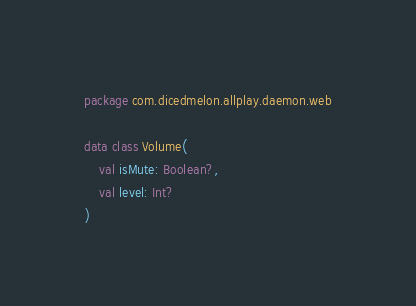<code> <loc_0><loc_0><loc_500><loc_500><_Kotlin_>package com.dicedmelon.allplay.daemon.web

data class Volume(
    val isMute: Boolean?,
    val level: Int?
)
</code> 